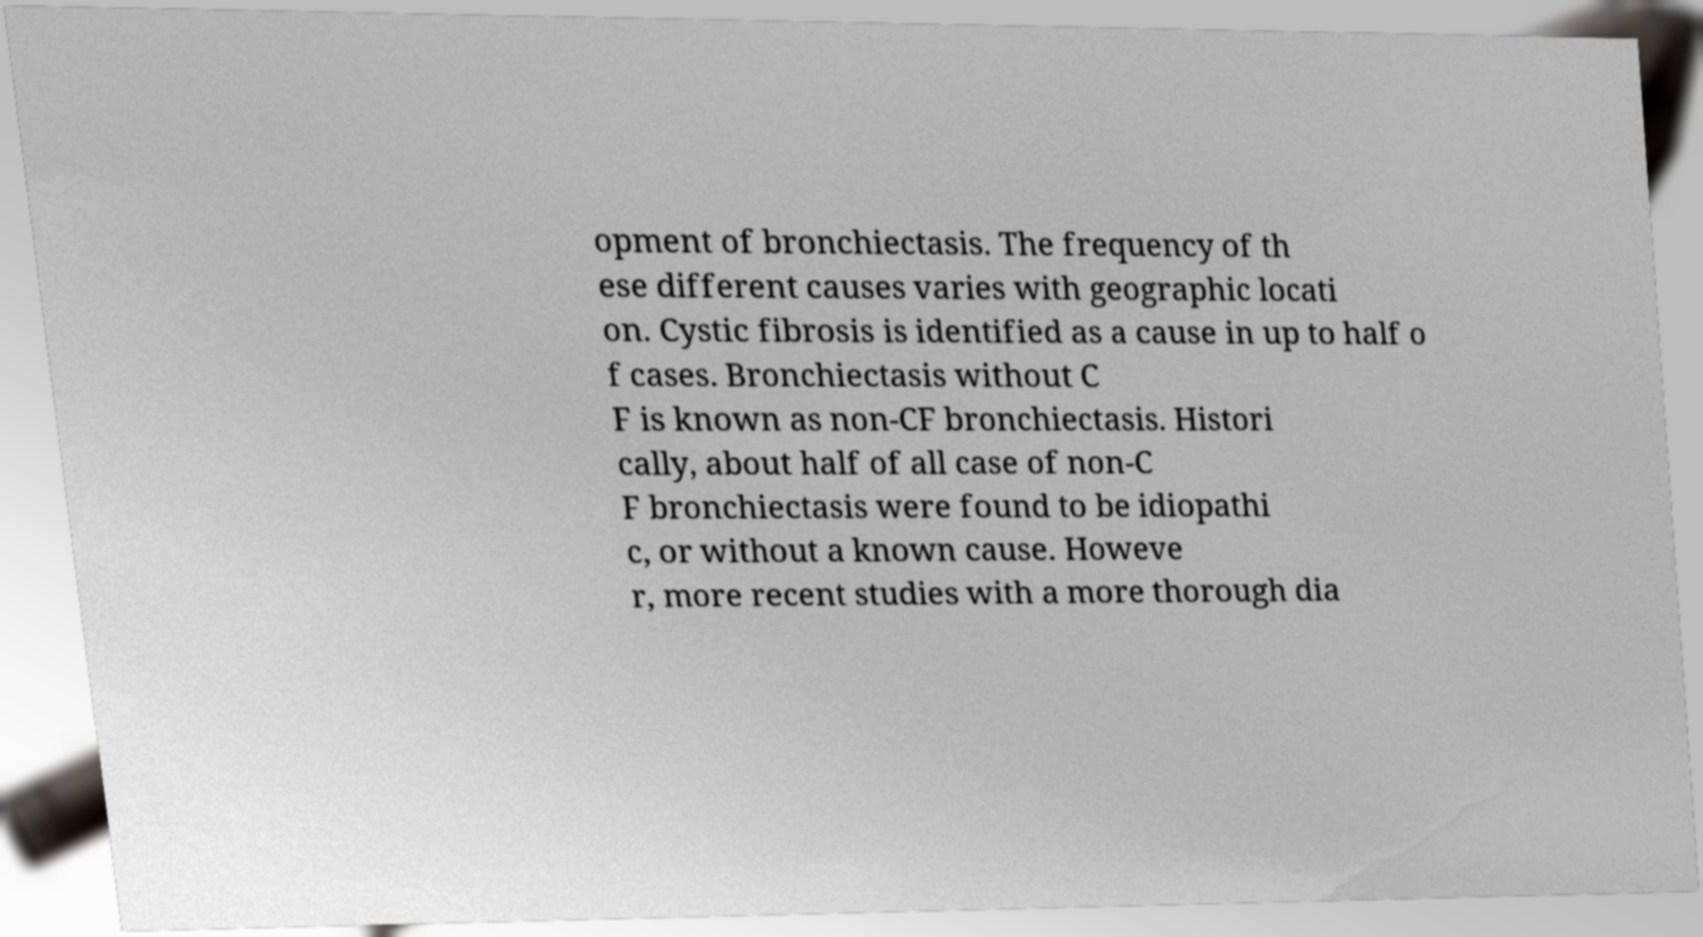Please identify and transcribe the text found in this image. opment of bronchiectasis. The frequency of th ese different causes varies with geographic locati on. Cystic fibrosis is identified as a cause in up to half o f cases. Bronchiectasis without C F is known as non-CF bronchiectasis. Histori cally, about half of all case of non-C F bronchiectasis were found to be idiopathi c, or without a known cause. Howeve r, more recent studies with a more thorough dia 